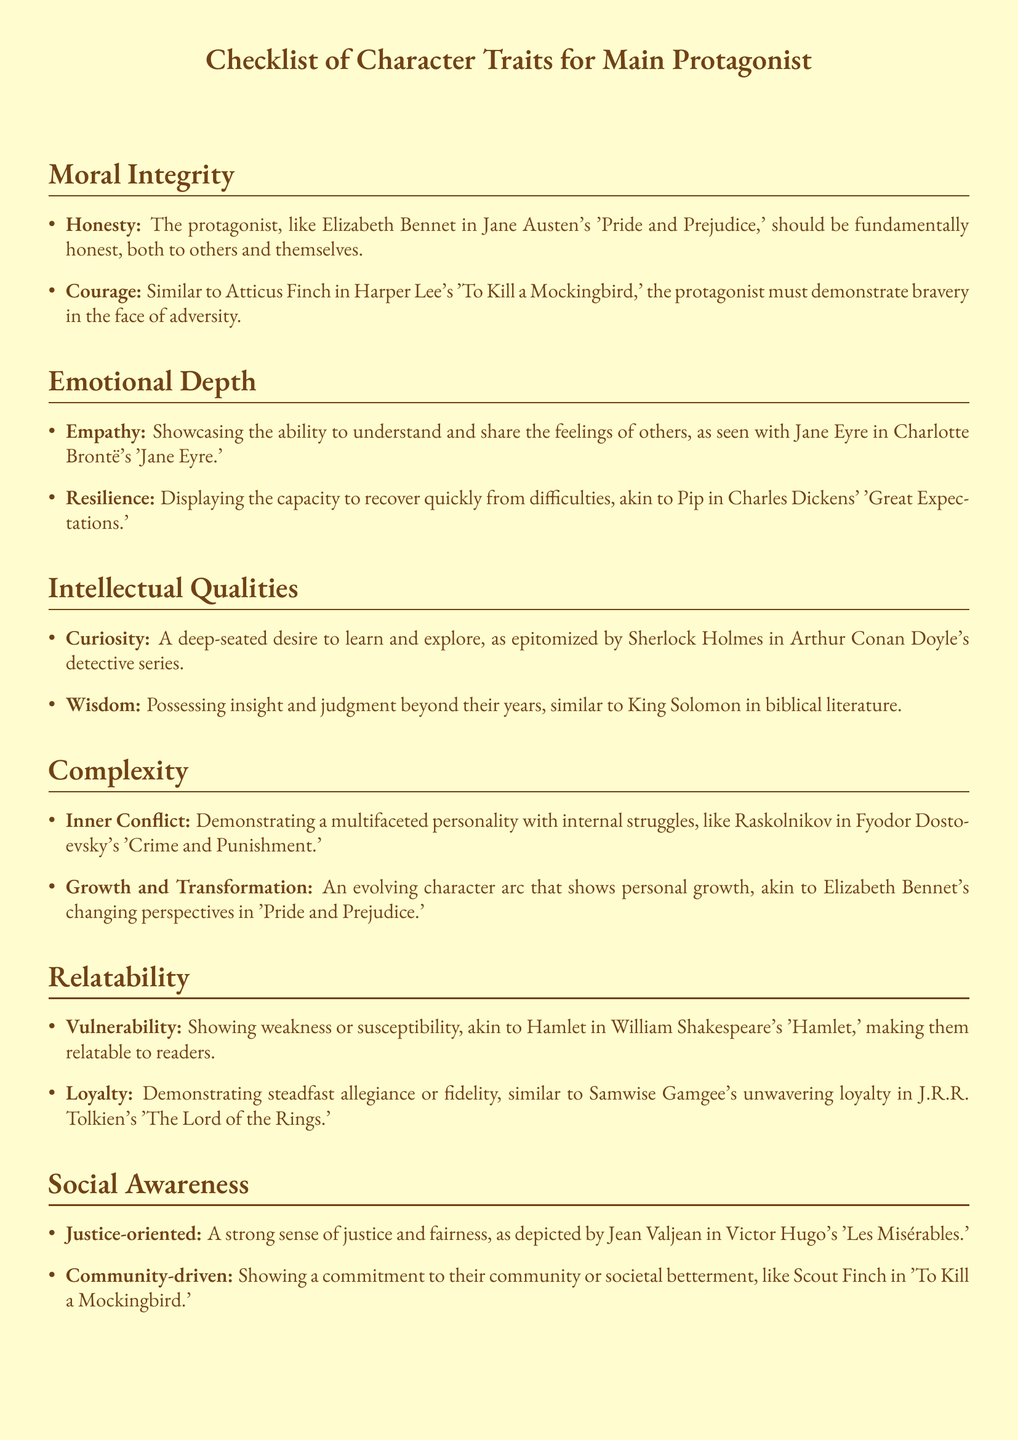What is the first trait listed under Moral Integrity? The first trait listed is a specific quality that characterizes the protagonist's moral compass, which is stated as "Honesty."
Answer: Honesty Who is the protagonist compared to for showing Courage? The document provides a specific character from literature that exemplifies Courage, which helps to clarify the trait's representation.
Answer: Atticus Finch How many traits are listed under Emotional Depth? The count of traits in a specific section conveys how extensively the document elaborates on the theme of Emotional Depth.
Answer: 2 What character trait involves understanding others' feelings? This trait specifically addresses the protagonist's ability to connect with others' emotions, highlighting their empathetic nature.
Answer: Empathy Which character's loyalty is referenced in the Relatability section? Identifying the character noted for their loyalty provides insight into the expected qualities and dedication of the protagonist.
Answer: Samwise Gamgee What is the trait that describes the protagonist's evolving character arc? This term is used to encapsulate the protagonist's journey of change and development throughout the narrative.
Answer: Growth and Transformation Which section discusses a character's sense of justice? Determining the section dedicated to social and moral values highlights the protagonist's role within societal contexts.
Answer: Social Awareness What does the term "Distinct Voice" refer to in the checklist? Understanding this aspect will clarify the uniqueness and individuality of the protagonist's narrative style, which is outlined in the document.
Answer: Unique narrative voice 